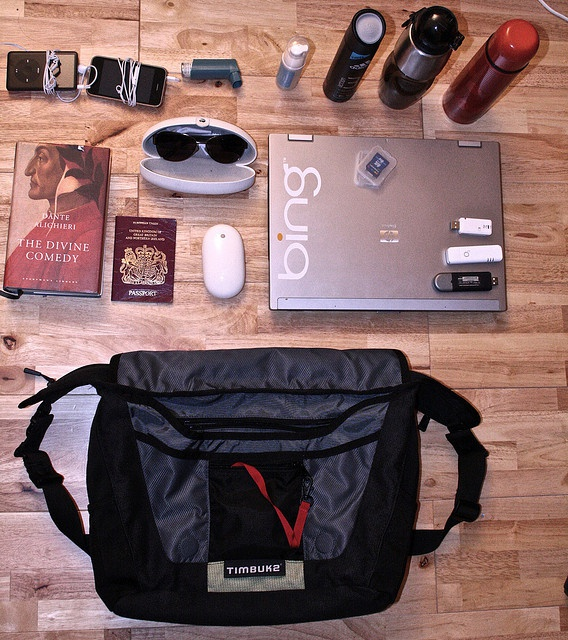Describe the objects in this image and their specific colors. I can see backpack in tan, black, and gray tones, handbag in tan, black, gray, and darkgray tones, laptop in tan, darkgray, gray, and lavender tones, book in tan, brown, lightpink, and salmon tones, and book in tan, maroon, brown, purple, and lightpink tones in this image. 